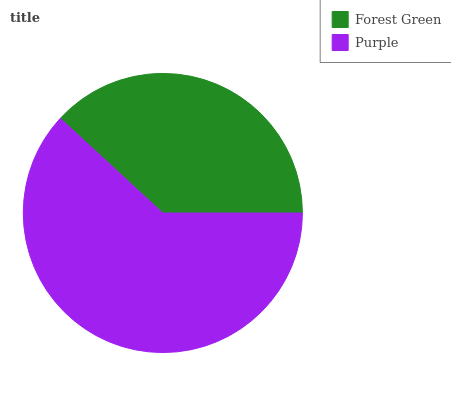Is Forest Green the minimum?
Answer yes or no. Yes. Is Purple the maximum?
Answer yes or no. Yes. Is Purple the minimum?
Answer yes or no. No. Is Purple greater than Forest Green?
Answer yes or no. Yes. Is Forest Green less than Purple?
Answer yes or no. Yes. Is Forest Green greater than Purple?
Answer yes or no. No. Is Purple less than Forest Green?
Answer yes or no. No. Is Purple the high median?
Answer yes or no. Yes. Is Forest Green the low median?
Answer yes or no. Yes. Is Forest Green the high median?
Answer yes or no. No. Is Purple the low median?
Answer yes or no. No. 